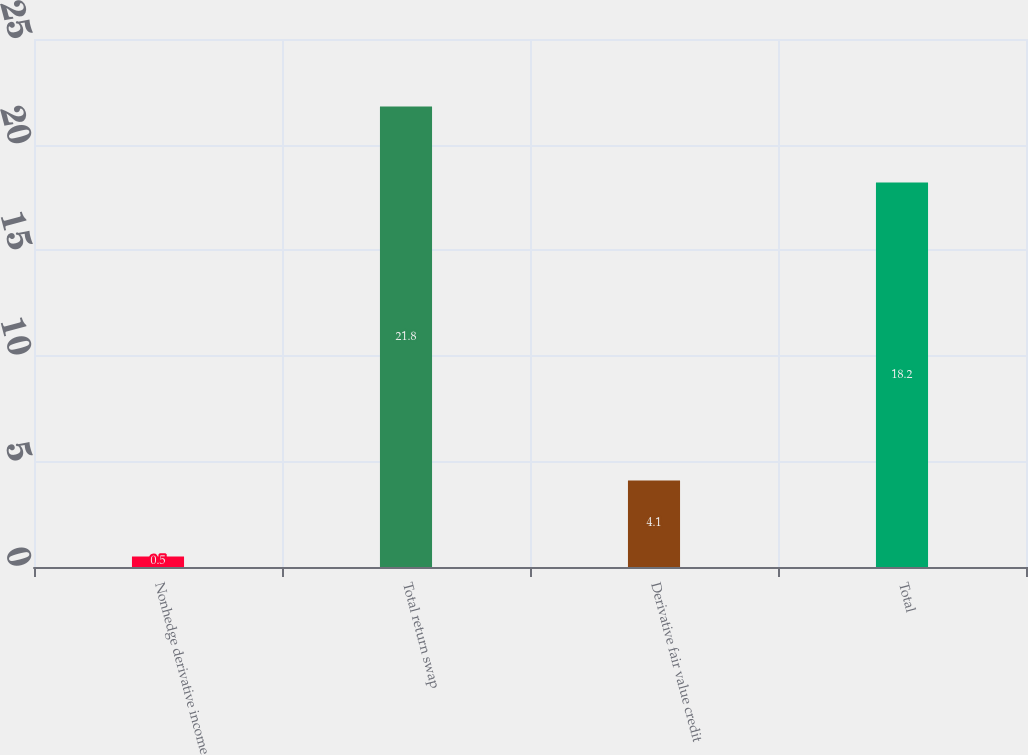<chart> <loc_0><loc_0><loc_500><loc_500><bar_chart><fcel>Nonhedge derivative income<fcel>Total return swap<fcel>Derivative fair value credit<fcel>Total<nl><fcel>0.5<fcel>21.8<fcel>4.1<fcel>18.2<nl></chart> 